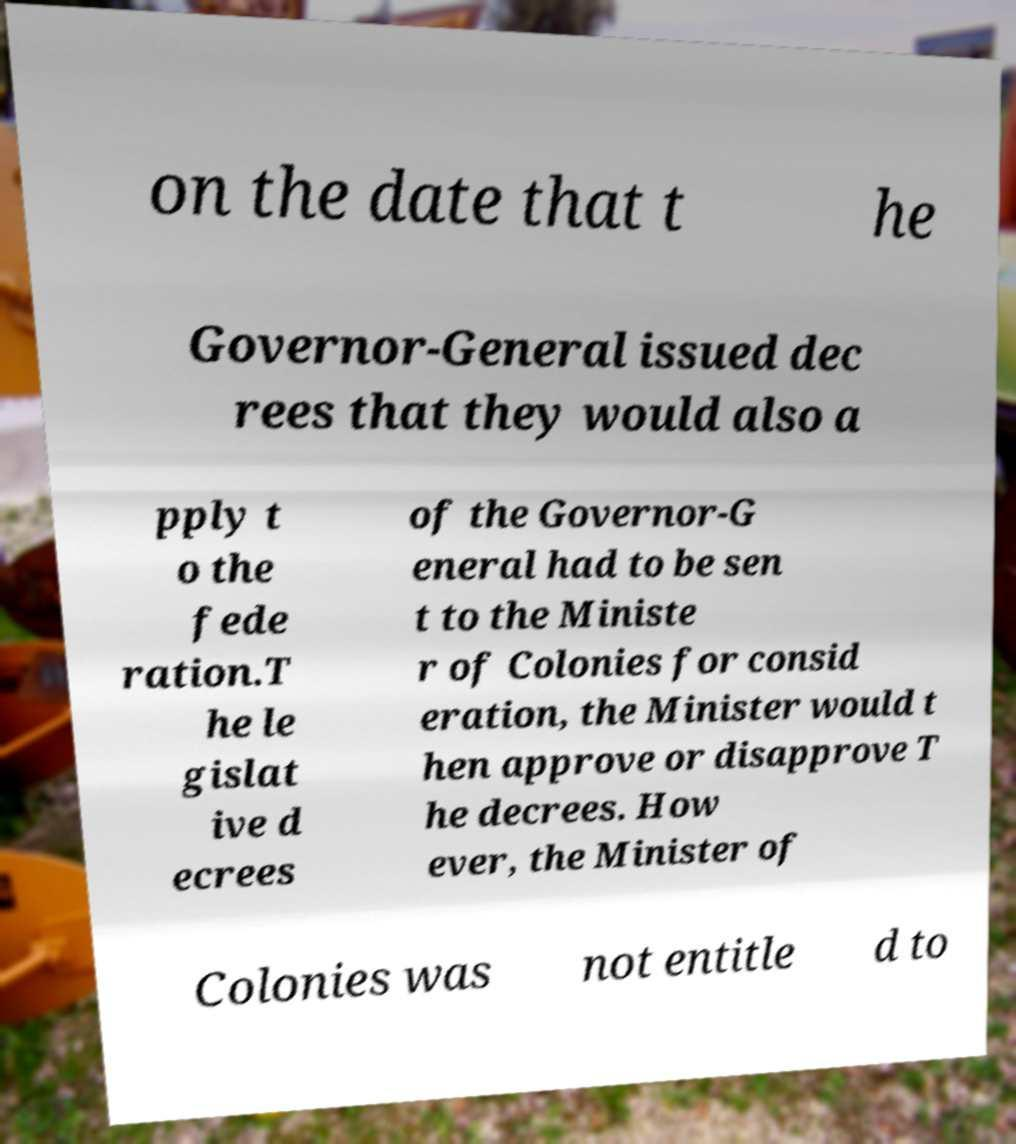What messages or text are displayed in this image? I need them in a readable, typed format. on the date that t he Governor-General issued dec rees that they would also a pply t o the fede ration.T he le gislat ive d ecrees of the Governor-G eneral had to be sen t to the Ministe r of Colonies for consid eration, the Minister would t hen approve or disapprove T he decrees. How ever, the Minister of Colonies was not entitle d to 